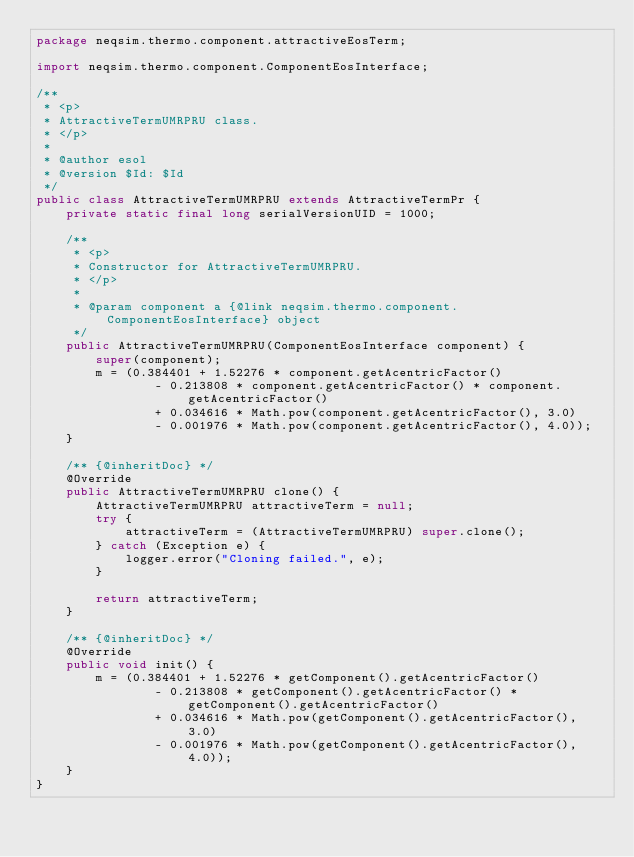Convert code to text. <code><loc_0><loc_0><loc_500><loc_500><_Java_>package neqsim.thermo.component.attractiveEosTerm;

import neqsim.thermo.component.ComponentEosInterface;

/**
 * <p>
 * AttractiveTermUMRPRU class.
 * </p>
 *
 * @author esol
 * @version $Id: $Id
 */
public class AttractiveTermUMRPRU extends AttractiveTermPr {
    private static final long serialVersionUID = 1000;

    /**
     * <p>
     * Constructor for AttractiveTermUMRPRU.
     * </p>
     *
     * @param component a {@link neqsim.thermo.component.ComponentEosInterface} object
     */
    public AttractiveTermUMRPRU(ComponentEosInterface component) {
        super(component);
        m = (0.384401 + 1.52276 * component.getAcentricFactor()
                - 0.213808 * component.getAcentricFactor() * component.getAcentricFactor()
                + 0.034616 * Math.pow(component.getAcentricFactor(), 3.0)
                - 0.001976 * Math.pow(component.getAcentricFactor(), 4.0));
    }

    /** {@inheritDoc} */
    @Override
    public AttractiveTermUMRPRU clone() {
        AttractiveTermUMRPRU attractiveTerm = null;
        try {
            attractiveTerm = (AttractiveTermUMRPRU) super.clone();
        } catch (Exception e) {
            logger.error("Cloning failed.", e);
        }

        return attractiveTerm;
    }

    /** {@inheritDoc} */
    @Override
    public void init() {
        m = (0.384401 + 1.52276 * getComponent().getAcentricFactor()
                - 0.213808 * getComponent().getAcentricFactor() * getComponent().getAcentricFactor()
                + 0.034616 * Math.pow(getComponent().getAcentricFactor(), 3.0)
                - 0.001976 * Math.pow(getComponent().getAcentricFactor(), 4.0));
    }
}
</code> 